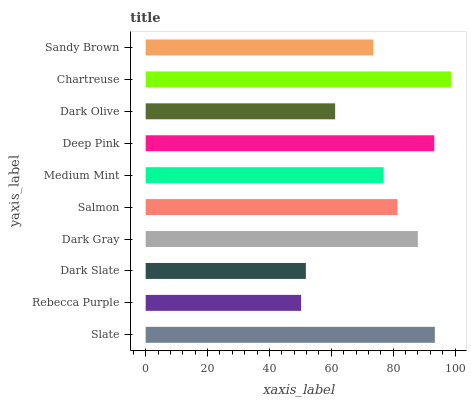Is Rebecca Purple the minimum?
Answer yes or no. Yes. Is Chartreuse the maximum?
Answer yes or no. Yes. Is Dark Slate the minimum?
Answer yes or no. No. Is Dark Slate the maximum?
Answer yes or no. No. Is Dark Slate greater than Rebecca Purple?
Answer yes or no. Yes. Is Rebecca Purple less than Dark Slate?
Answer yes or no. Yes. Is Rebecca Purple greater than Dark Slate?
Answer yes or no. No. Is Dark Slate less than Rebecca Purple?
Answer yes or no. No. Is Salmon the high median?
Answer yes or no. Yes. Is Medium Mint the low median?
Answer yes or no. Yes. Is Chartreuse the high median?
Answer yes or no. No. Is Dark Slate the low median?
Answer yes or no. No. 